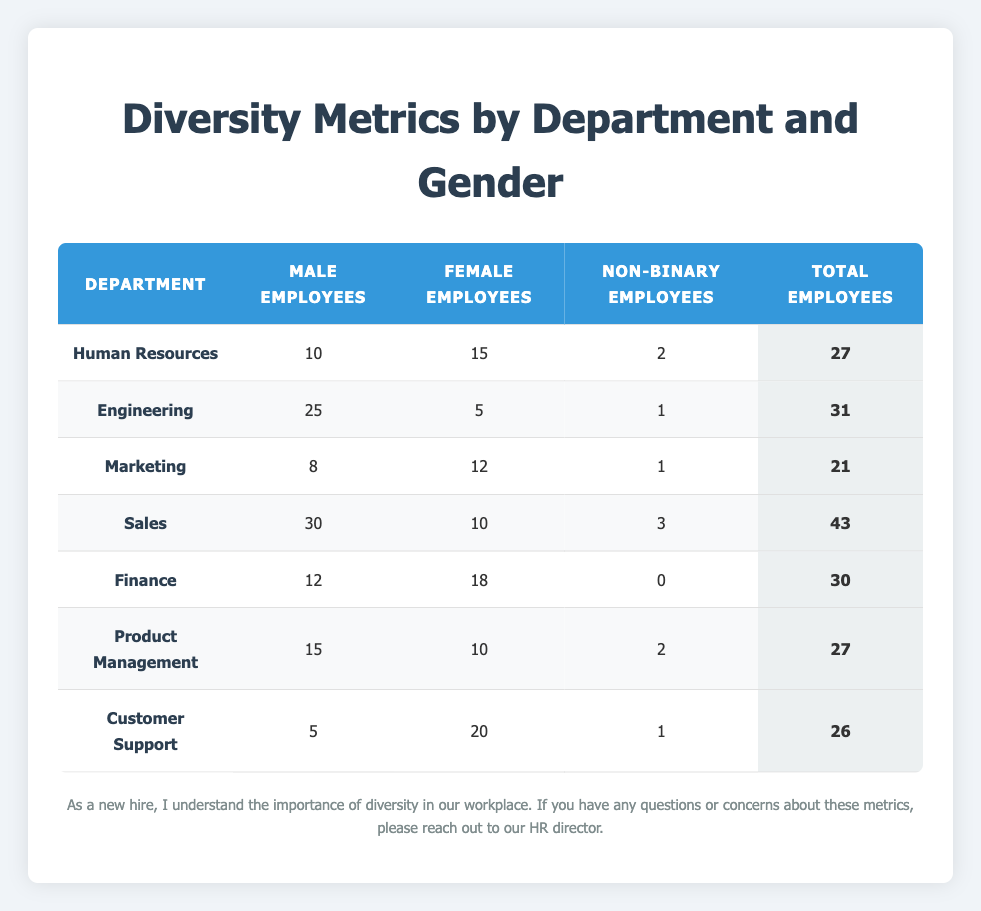What is the total number of male employees in the Engineering department? The Engineering department has 25 male employees listed in the table.
Answer: 25 Which department has the highest number of female employees? By comparing the Female Employees column, Customer Support has 20 female employees, which is the highest.
Answer: Customer Support How many more male employees are there in Sales than in Marketing? Sales has 30 male employees and Marketing has 8. The difference is 30 - 8 = 22.
Answer: 22 True or False: The Finance department has more male employees than the Engineering department. Finance has 12 male employees, while Engineering has 25. Thus, the statement is false.
Answer: False What is the combined total of non-binary employees in the Human Resources and Product Management departments? Human Resources has 2 non-binary employees and Product Management has 2 as well. Adding these gives 2 + 2 = 4.
Answer: 4 Which department has the lowest total number of employees? By examining the Total Employees column, Marketing has the lowest total at 21 employees.
Answer: Marketing What percentage of the total employees in Customer Support are female? Customer Support has 20 female employees out of a total of 26. To find the percentage, (20 / 26) * 100 = 76.92%.
Answer: Approximately 76.9% How many total employees are there across all departments? Total employees can be calculated by summing all the values in the Total Employees column: 27 + 31 + 21 + 43 + 30 + 27 + 26 = 205.
Answer: 205 Is there any department where the number of female employees exceeds the number of male employees? Looking at the numbers, Customer Support has 20 female employees and 5 male employees. Thus, yes, it is true.
Answer: Yes 